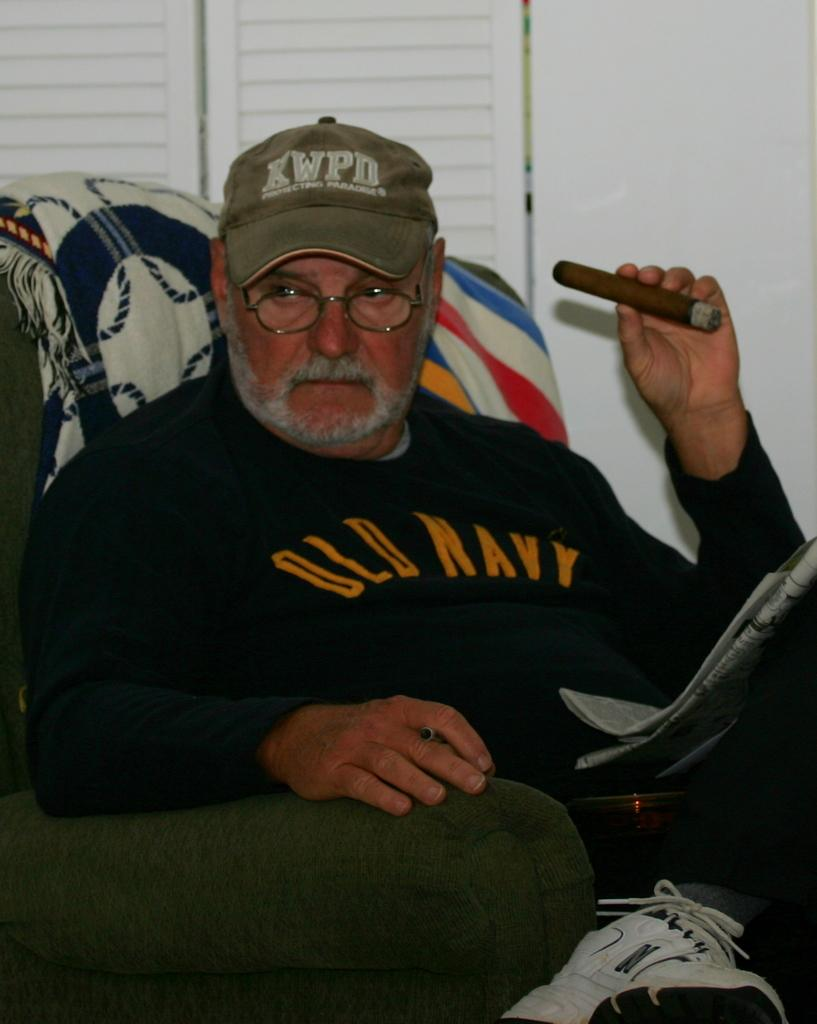<image>
Relay a brief, clear account of the picture shown. The man in the chair is wearing an Old Navy sweatshirt and a KWPD cap. 